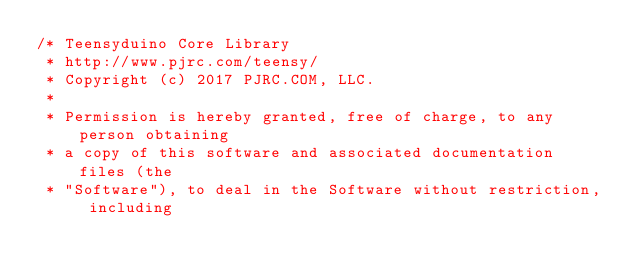Convert code to text. <code><loc_0><loc_0><loc_500><loc_500><_C++_>/* Teensyduino Core Library
 * http://www.pjrc.com/teensy/
 * Copyright (c) 2017 PJRC.COM, LLC.
 *
 * Permission is hereby granted, free of charge, to any person obtaining
 * a copy of this software and associated documentation files (the
 * "Software"), to deal in the Software without restriction, including</code> 